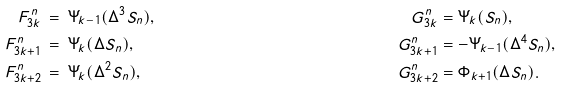<formula> <loc_0><loc_0><loc_500><loc_500>F _ { 3 k } ^ { n } & \, = \, \Psi _ { k - 1 } ( \Delta ^ { 3 } S _ { n } ) , \ & G _ { 3 k } ^ { n } & = \Psi _ { k } ( S _ { n } ) , \\ F _ { 3 k + 1 } ^ { n } & \, = \, \Psi _ { k } ( \Delta S _ { n } ) , \ & G _ { 3 k + 1 } ^ { n } & = - \Psi _ { k - 1 } ( \Delta ^ { 4 } S _ { n } ) , \\ F _ { 3 k + 2 } ^ { n } & \, = \, \Psi _ { k } ( \Delta ^ { 2 } S _ { n } ) , \ & G _ { 3 k + 2 } ^ { n } & = \Phi _ { k + 1 } ( \Delta S _ { n } ) .</formula> 